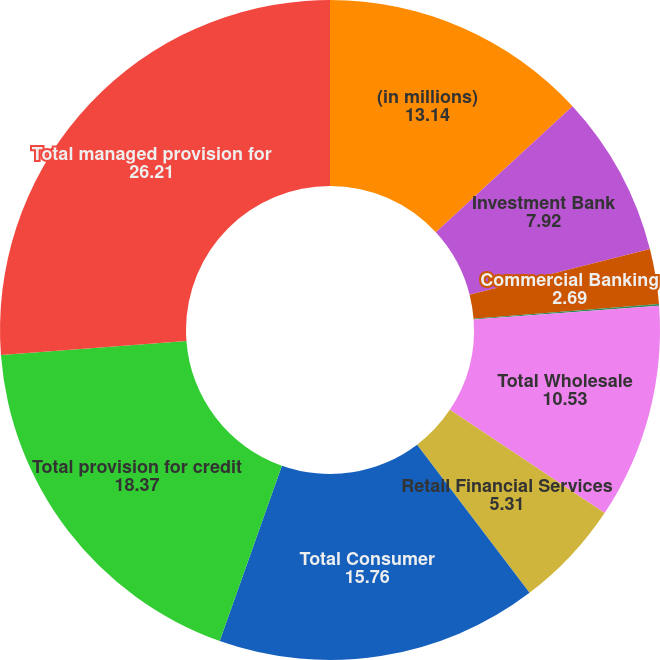Convert chart. <chart><loc_0><loc_0><loc_500><loc_500><pie_chart><fcel>(in millions)<fcel>Investment Bank<fcel>Commercial Banking<fcel>Asset & Wealth Management<fcel>Total Wholesale<fcel>Retail Financial Services<fcel>Total Consumer<fcel>Total provision for credit<fcel>Total managed provision for<nl><fcel>13.14%<fcel>7.92%<fcel>2.69%<fcel>0.08%<fcel>10.53%<fcel>5.31%<fcel>15.76%<fcel>18.37%<fcel>26.21%<nl></chart> 